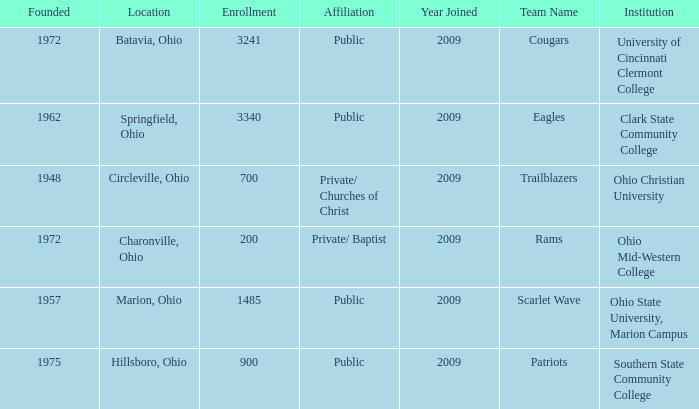What is the affiliation when the institution was ohio christian university? Private/ Churches of Christ. 